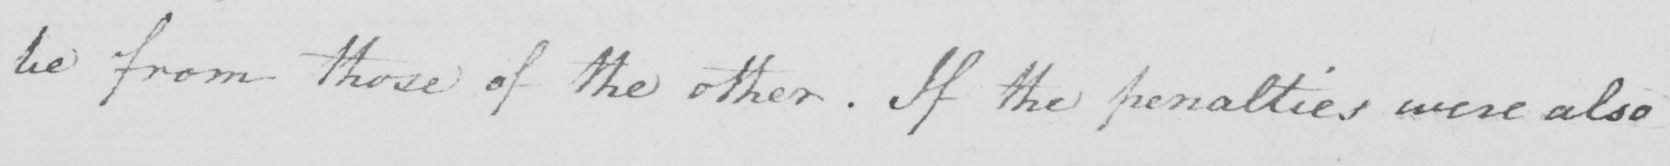Can you tell me what this handwritten text says? be from those of the other  . If the penalties were also 